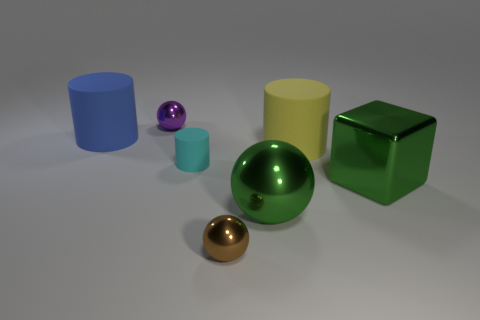The metallic thing that is the same color as the large shiny ball is what size?
Make the answer very short. Large. There is a rubber object on the left side of the small ball that is behind the yellow cylinder; is there a small cyan matte object that is in front of it?
Give a very brief answer. Yes. How many matte things are small cyan cylinders or spheres?
Keep it short and to the point. 1. Do the cube and the tiny cylinder have the same color?
Give a very brief answer. No. What number of cyan matte objects are in front of the tiny purple thing?
Your answer should be very brief. 1. How many things are both in front of the big yellow cylinder and on the right side of the brown ball?
Your response must be concise. 2. What shape is the large thing that is the same material as the big yellow cylinder?
Offer a terse response. Cylinder. There is a green metallic object that is in front of the large metal cube; does it have the same size as the blue object behind the cyan object?
Offer a terse response. Yes. There is a big rubber object that is behind the yellow cylinder; what color is it?
Ensure brevity in your answer.  Blue. What material is the ball on the left side of the small thing in front of the big shiny cube?
Your answer should be compact. Metal. 